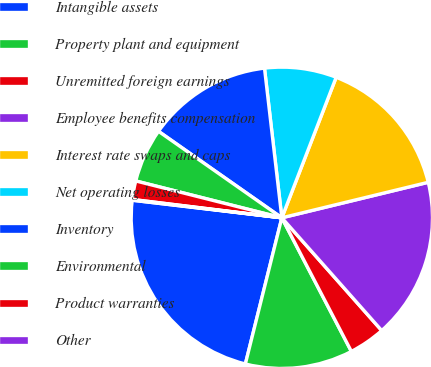<chart> <loc_0><loc_0><loc_500><loc_500><pie_chart><fcel>Intangible assets<fcel>Property plant and equipment<fcel>Unremitted foreign earnings<fcel>Employee benefits compensation<fcel>Interest rate swaps and caps<fcel>Net operating losses<fcel>Inventory<fcel>Environmental<fcel>Product warranties<fcel>Other<nl><fcel>22.97%<fcel>11.53%<fcel>3.9%<fcel>17.25%<fcel>15.34%<fcel>7.71%<fcel>13.43%<fcel>5.8%<fcel>1.99%<fcel>0.08%<nl></chart> 